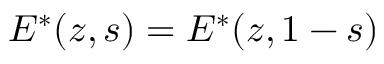Convert formula to latex. <formula><loc_0><loc_0><loc_500><loc_500>E ^ { * } ( z , s ) = E ^ { * } ( z , 1 - s )</formula> 